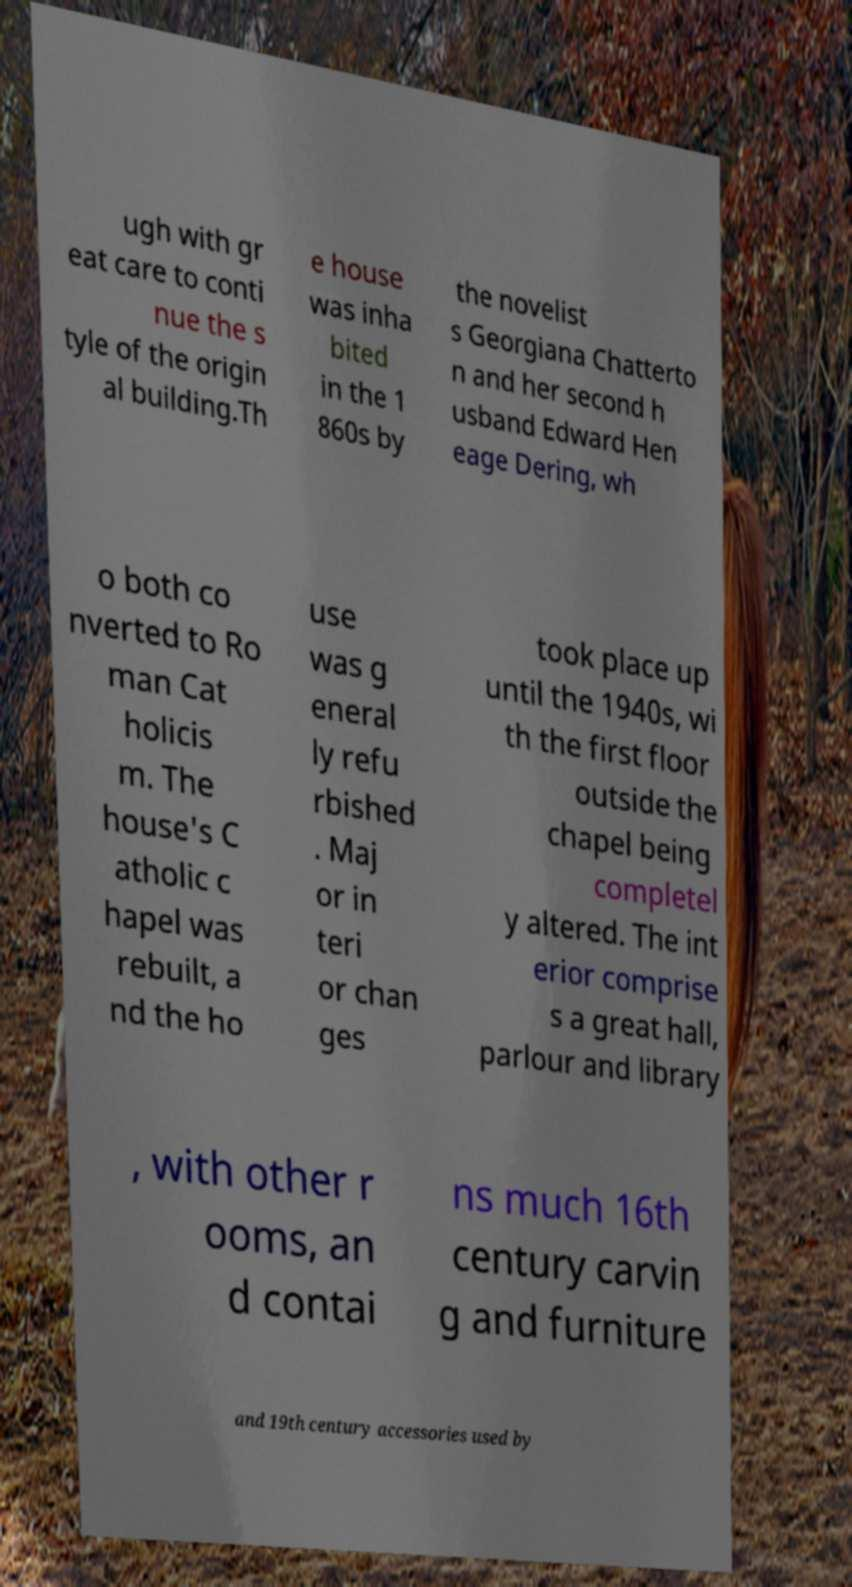Please identify and transcribe the text found in this image. ugh with gr eat care to conti nue the s tyle of the origin al building.Th e house was inha bited in the 1 860s by the novelist s Georgiana Chatterto n and her second h usband Edward Hen eage Dering, wh o both co nverted to Ro man Cat holicis m. The house's C atholic c hapel was rebuilt, a nd the ho use was g eneral ly refu rbished . Maj or in teri or chan ges took place up until the 1940s, wi th the first floor outside the chapel being completel y altered. The int erior comprise s a great hall, parlour and library , with other r ooms, an d contai ns much 16th century carvin g and furniture and 19th century accessories used by 